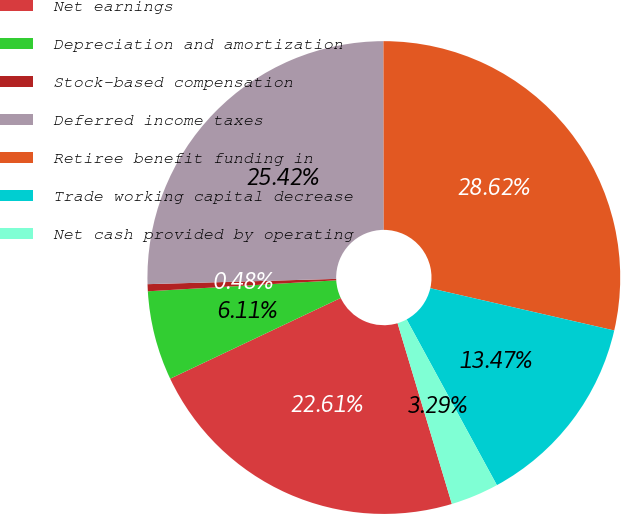Convert chart. <chart><loc_0><loc_0><loc_500><loc_500><pie_chart><fcel>Net earnings<fcel>Depreciation and amortization<fcel>Stock-based compensation<fcel>Deferred income taxes<fcel>Retiree benefit funding in<fcel>Trade working capital decrease<fcel>Net cash provided by operating<nl><fcel>22.61%<fcel>6.11%<fcel>0.48%<fcel>25.42%<fcel>28.62%<fcel>13.47%<fcel>3.29%<nl></chart> 